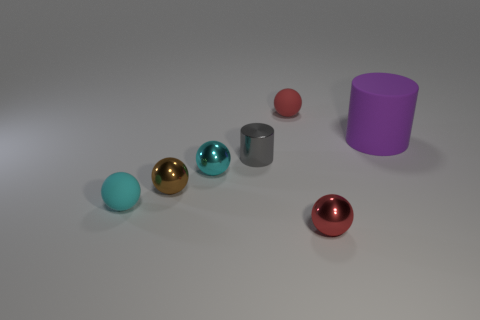There is a matte thing in front of the tiny cyan metallic object; what color is it?
Offer a terse response. Cyan. Does the purple thing have the same material as the brown ball?
Your answer should be compact. No. How many objects are rubber things or small metallic objects behind the cyan matte sphere?
Keep it short and to the point. 6. The tiny red object that is in front of the matte cylinder has what shape?
Offer a terse response. Sphere. There is a tiny matte object in front of the big thing; is its color the same as the large rubber thing?
Your answer should be compact. No. Does the cylinder to the left of the purple matte thing have the same size as the large purple matte cylinder?
Make the answer very short. No. Are there any blocks of the same color as the big rubber thing?
Offer a very short reply. No. Is there a thing that is behind the small thing behind the large matte cylinder?
Your answer should be compact. No. Is there a tiny blue block that has the same material as the brown thing?
Ensure brevity in your answer.  No. What is the material of the tiny cyan ball that is on the right side of the tiny cyan ball in front of the small brown shiny object?
Your answer should be compact. Metal. 